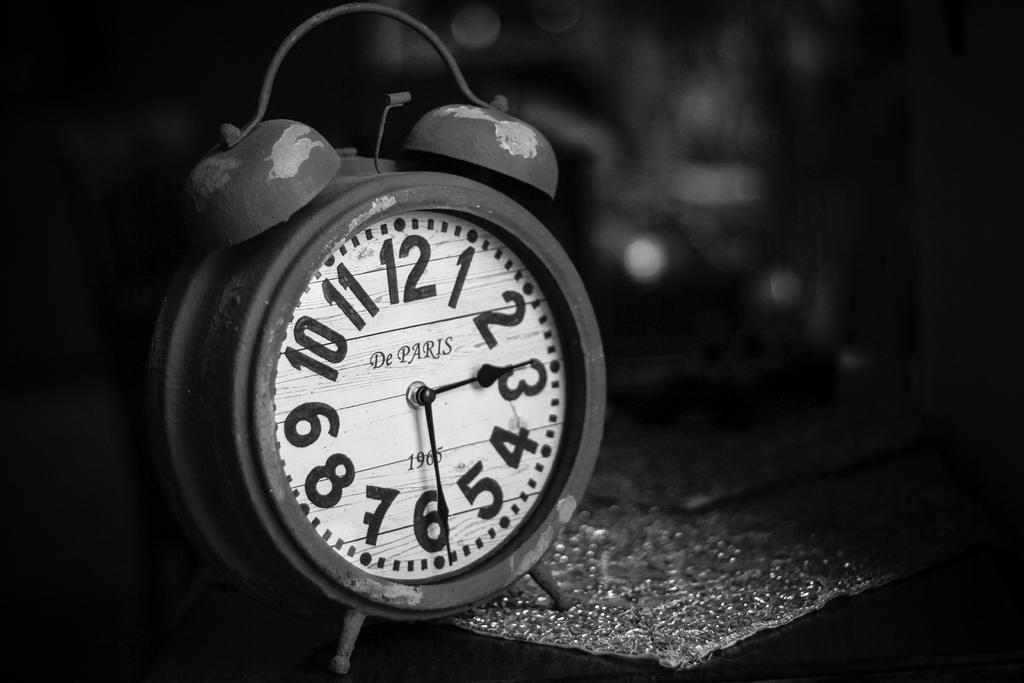What time is shown on the clock?
Your response must be concise. 2:30. What city is written on the clock?
Offer a very short reply. Paris. 